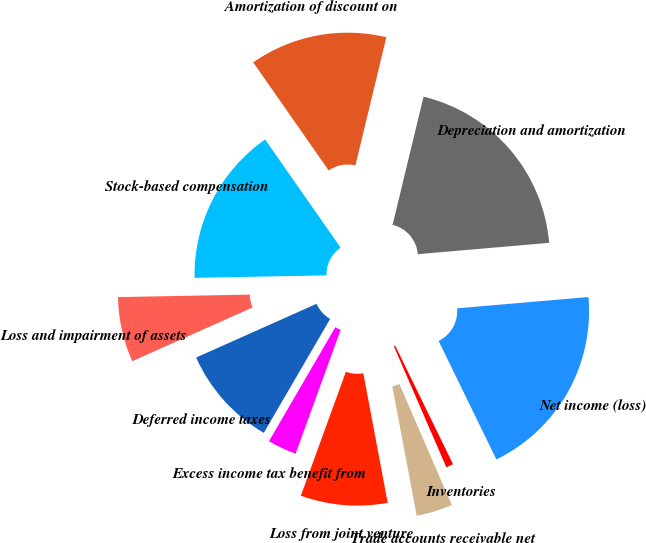Convert chart to OTSL. <chart><loc_0><loc_0><loc_500><loc_500><pie_chart><fcel>Net income (loss)<fcel>Depreciation and amortization<fcel>Amortization of discount on<fcel>Stock-based compensation<fcel>Loss and impairment of assets<fcel>Deferred income taxes<fcel>Excess income tax benefit from<fcel>Loss from joint venture<fcel>Trade accounts receivable net<fcel>Inventories<nl><fcel>19.15%<fcel>19.86%<fcel>13.47%<fcel>15.6%<fcel>6.38%<fcel>9.93%<fcel>2.84%<fcel>8.51%<fcel>3.55%<fcel>0.71%<nl></chart> 